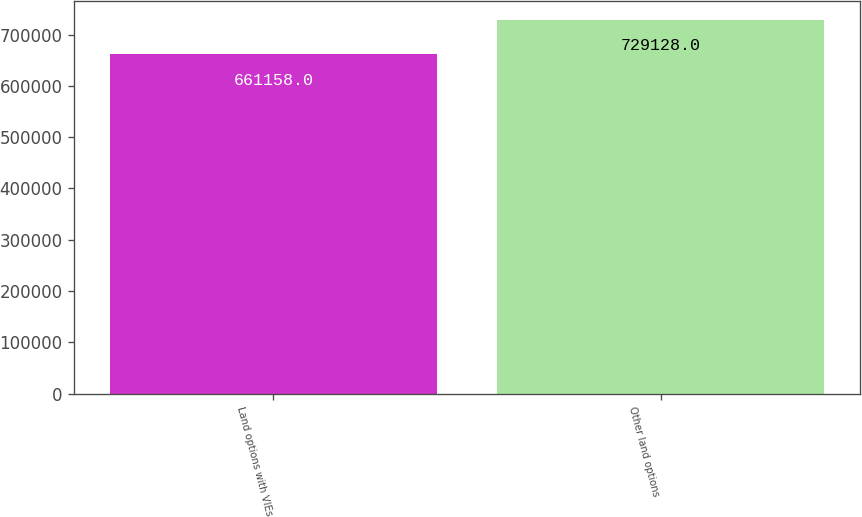<chart> <loc_0><loc_0><loc_500><loc_500><bar_chart><fcel>Land options with VIEs<fcel>Other land options<nl><fcel>661158<fcel>729128<nl></chart> 